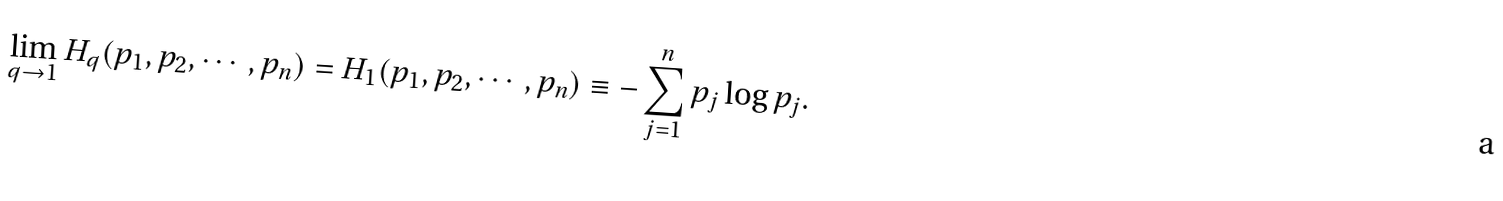Convert formula to latex. <formula><loc_0><loc_0><loc_500><loc_500>\lim _ { q \rightarrow 1 } H _ { q } ( p _ { 1 } , p _ { 2 } , \cdots , p _ { n } ) = H _ { 1 } ( p _ { 1 } , p _ { 2 } , \cdots , p _ { n } ) \equiv - \sum _ { j = 1 } ^ { n } p _ { j } \log p _ { j } .</formula> 